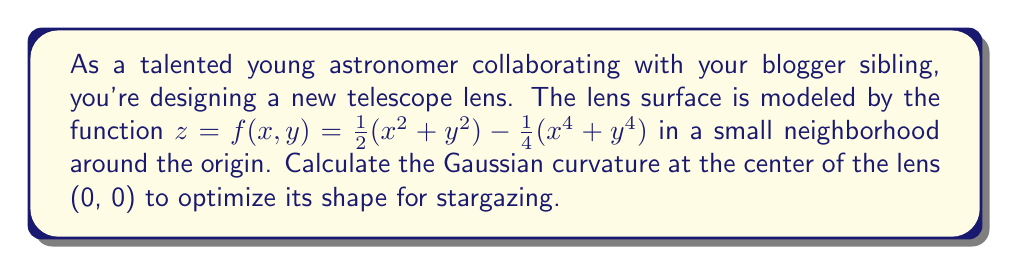Could you help me with this problem? To calculate the Gaussian curvature, we'll follow these steps:

1) The Gaussian curvature K is given by:

   $$K = \frac{f_{xx}f_{yy} - f_{xy}^2}{(1 + f_x^2 + f_y^2)^2}$$

   where subscripts denote partial derivatives.

2) Calculate the required partial derivatives:
   
   $f_x = x - x^3$
   $f_y = y - y^3$
   $f_{xx} = 1 - 3x^2$
   $f_{yy} = 1 - 3y^2$
   $f_{xy} = 0$

3) Evaluate these at the center point (0, 0):
   
   $f_x(0,0) = 0$
   $f_y(0,0) = 0$
   $f_{xx}(0,0) = 1$
   $f_{yy}(0,0) = 1$
   $f_{xy}(0,0) = 0$

4) Substitute into the Gaussian curvature formula:

   $$K = \frac{(1)(1) - (0)^2}{(1 + 0^2 + 0^2)^2} = \frac{1}{1^2} = 1$$

Thus, the Gaussian curvature at the center of the lens is 1.
Answer: $K = 1$ 